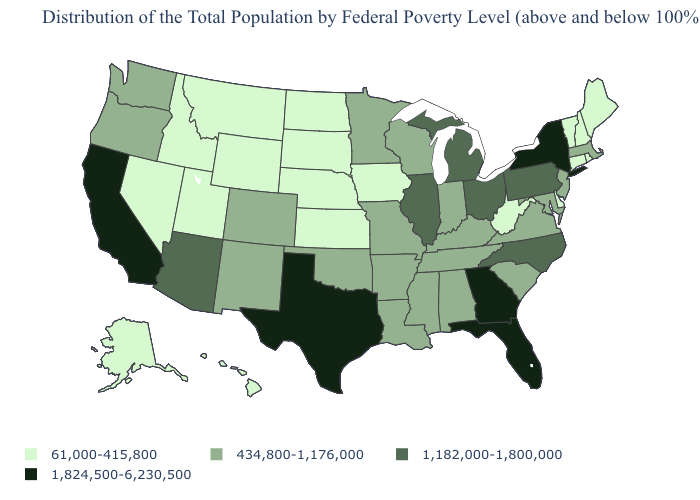What is the value of Indiana?
Give a very brief answer. 434,800-1,176,000. What is the value of Wisconsin?
Quick response, please. 434,800-1,176,000. What is the value of South Carolina?
Short answer required. 434,800-1,176,000. What is the value of Minnesota?
Be succinct. 434,800-1,176,000. Which states have the highest value in the USA?
Be succinct. California, Florida, Georgia, New York, Texas. Name the states that have a value in the range 1,824,500-6,230,500?
Short answer required. California, Florida, Georgia, New York, Texas. Is the legend a continuous bar?
Be succinct. No. Does Florida have the highest value in the South?
Keep it brief. Yes. Does Delaware have the lowest value in the USA?
Keep it brief. Yes. Name the states that have a value in the range 1,182,000-1,800,000?
Short answer required. Arizona, Illinois, Michigan, North Carolina, Ohio, Pennsylvania. Does Montana have the lowest value in the USA?
Short answer required. Yes. What is the value of Utah?
Concise answer only. 61,000-415,800. Name the states that have a value in the range 61,000-415,800?
Keep it brief. Alaska, Connecticut, Delaware, Hawaii, Idaho, Iowa, Kansas, Maine, Montana, Nebraska, Nevada, New Hampshire, North Dakota, Rhode Island, South Dakota, Utah, Vermont, West Virginia, Wyoming. What is the value of New Hampshire?
Write a very short answer. 61,000-415,800. What is the value of Iowa?
Give a very brief answer. 61,000-415,800. 